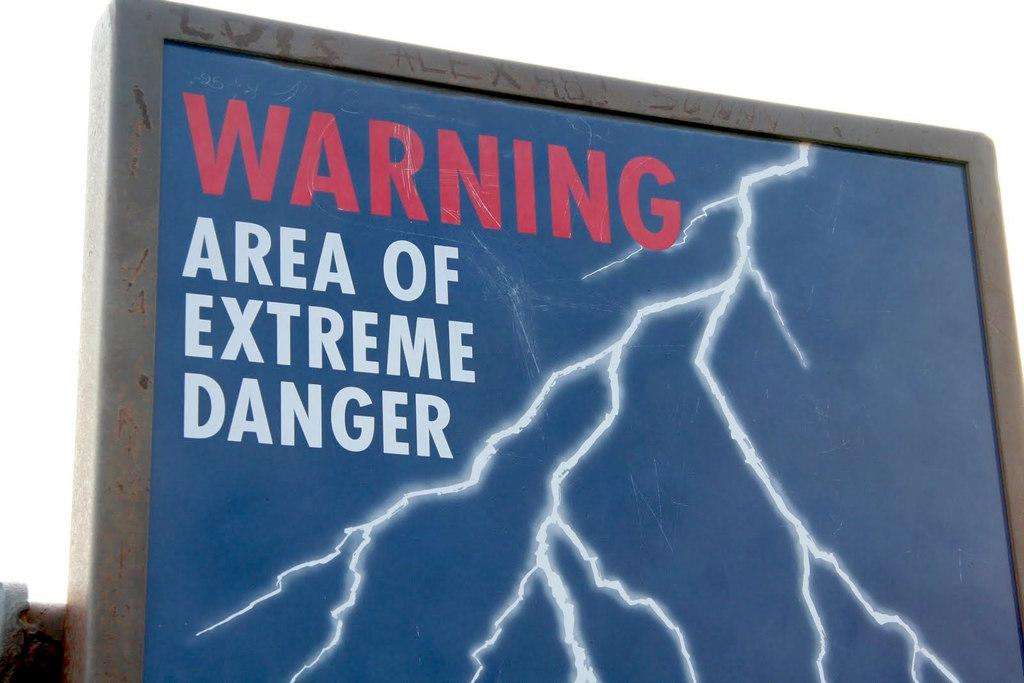<image>
Share a concise interpretation of the image provided. A large sign says Warning Area of Extreme Danger. 